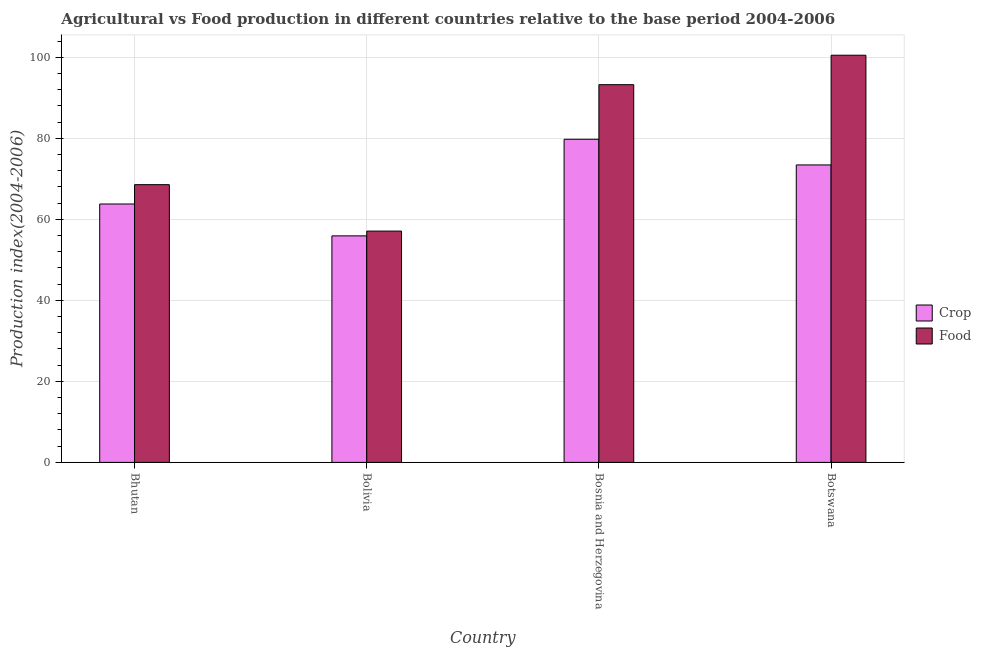How many groups of bars are there?
Your response must be concise. 4. How many bars are there on the 2nd tick from the left?
Your answer should be very brief. 2. How many bars are there on the 1st tick from the right?
Keep it short and to the point. 2. What is the label of the 4th group of bars from the left?
Provide a short and direct response. Botswana. What is the food production index in Bhutan?
Give a very brief answer. 68.56. Across all countries, what is the maximum crop production index?
Provide a succinct answer. 79.77. Across all countries, what is the minimum food production index?
Keep it short and to the point. 57.1. In which country was the food production index maximum?
Make the answer very short. Botswana. What is the total crop production index in the graph?
Offer a terse response. 272.91. What is the difference between the crop production index in Bhutan and that in Botswana?
Ensure brevity in your answer.  -9.64. What is the difference between the food production index in Bolivia and the crop production index in Botswana?
Keep it short and to the point. -16.33. What is the average food production index per country?
Offer a very short reply. 79.85. What is the difference between the food production index and crop production index in Bosnia and Herzegovina?
Offer a terse response. 13.47. In how many countries, is the food production index greater than 64 ?
Give a very brief answer. 3. What is the ratio of the food production index in Bhutan to that in Botswana?
Offer a very short reply. 0.68. Is the crop production index in Bolivia less than that in Botswana?
Ensure brevity in your answer.  Yes. What is the difference between the highest and the second highest food production index?
Give a very brief answer. 7.27. What is the difference between the highest and the lowest food production index?
Offer a very short reply. 43.41. In how many countries, is the crop production index greater than the average crop production index taken over all countries?
Your answer should be compact. 2. What does the 1st bar from the left in Botswana represents?
Your answer should be very brief. Crop. What does the 2nd bar from the right in Bosnia and Herzegovina represents?
Provide a succinct answer. Crop. How many bars are there?
Give a very brief answer. 8. How many countries are there in the graph?
Your response must be concise. 4. What is the difference between two consecutive major ticks on the Y-axis?
Your answer should be very brief. 20. Does the graph contain any zero values?
Give a very brief answer. No. Where does the legend appear in the graph?
Your answer should be very brief. Center right. What is the title of the graph?
Your answer should be compact. Agricultural vs Food production in different countries relative to the base period 2004-2006. What is the label or title of the X-axis?
Provide a short and direct response. Country. What is the label or title of the Y-axis?
Make the answer very short. Production index(2004-2006). What is the Production index(2004-2006) in Crop in Bhutan?
Your answer should be very brief. 63.79. What is the Production index(2004-2006) in Food in Bhutan?
Your answer should be very brief. 68.56. What is the Production index(2004-2006) of Crop in Bolivia?
Provide a succinct answer. 55.92. What is the Production index(2004-2006) in Food in Bolivia?
Your answer should be compact. 57.1. What is the Production index(2004-2006) in Crop in Bosnia and Herzegovina?
Your answer should be very brief. 79.77. What is the Production index(2004-2006) of Food in Bosnia and Herzegovina?
Your response must be concise. 93.24. What is the Production index(2004-2006) in Crop in Botswana?
Provide a short and direct response. 73.43. What is the Production index(2004-2006) in Food in Botswana?
Ensure brevity in your answer.  100.51. Across all countries, what is the maximum Production index(2004-2006) in Crop?
Keep it short and to the point. 79.77. Across all countries, what is the maximum Production index(2004-2006) of Food?
Your answer should be very brief. 100.51. Across all countries, what is the minimum Production index(2004-2006) of Crop?
Make the answer very short. 55.92. Across all countries, what is the minimum Production index(2004-2006) of Food?
Your answer should be compact. 57.1. What is the total Production index(2004-2006) in Crop in the graph?
Ensure brevity in your answer.  272.91. What is the total Production index(2004-2006) in Food in the graph?
Provide a short and direct response. 319.41. What is the difference between the Production index(2004-2006) of Crop in Bhutan and that in Bolivia?
Give a very brief answer. 7.87. What is the difference between the Production index(2004-2006) of Food in Bhutan and that in Bolivia?
Make the answer very short. 11.46. What is the difference between the Production index(2004-2006) of Crop in Bhutan and that in Bosnia and Herzegovina?
Provide a short and direct response. -15.98. What is the difference between the Production index(2004-2006) of Food in Bhutan and that in Bosnia and Herzegovina?
Ensure brevity in your answer.  -24.68. What is the difference between the Production index(2004-2006) in Crop in Bhutan and that in Botswana?
Your response must be concise. -9.64. What is the difference between the Production index(2004-2006) in Food in Bhutan and that in Botswana?
Provide a succinct answer. -31.95. What is the difference between the Production index(2004-2006) in Crop in Bolivia and that in Bosnia and Herzegovina?
Keep it short and to the point. -23.85. What is the difference between the Production index(2004-2006) of Food in Bolivia and that in Bosnia and Herzegovina?
Make the answer very short. -36.14. What is the difference between the Production index(2004-2006) in Crop in Bolivia and that in Botswana?
Your response must be concise. -17.51. What is the difference between the Production index(2004-2006) in Food in Bolivia and that in Botswana?
Your response must be concise. -43.41. What is the difference between the Production index(2004-2006) of Crop in Bosnia and Herzegovina and that in Botswana?
Offer a terse response. 6.34. What is the difference between the Production index(2004-2006) in Food in Bosnia and Herzegovina and that in Botswana?
Offer a very short reply. -7.27. What is the difference between the Production index(2004-2006) of Crop in Bhutan and the Production index(2004-2006) of Food in Bolivia?
Offer a terse response. 6.69. What is the difference between the Production index(2004-2006) in Crop in Bhutan and the Production index(2004-2006) in Food in Bosnia and Herzegovina?
Provide a succinct answer. -29.45. What is the difference between the Production index(2004-2006) of Crop in Bhutan and the Production index(2004-2006) of Food in Botswana?
Your response must be concise. -36.72. What is the difference between the Production index(2004-2006) in Crop in Bolivia and the Production index(2004-2006) in Food in Bosnia and Herzegovina?
Your response must be concise. -37.32. What is the difference between the Production index(2004-2006) in Crop in Bolivia and the Production index(2004-2006) in Food in Botswana?
Give a very brief answer. -44.59. What is the difference between the Production index(2004-2006) in Crop in Bosnia and Herzegovina and the Production index(2004-2006) in Food in Botswana?
Your answer should be compact. -20.74. What is the average Production index(2004-2006) of Crop per country?
Give a very brief answer. 68.23. What is the average Production index(2004-2006) in Food per country?
Keep it short and to the point. 79.85. What is the difference between the Production index(2004-2006) of Crop and Production index(2004-2006) of Food in Bhutan?
Provide a succinct answer. -4.77. What is the difference between the Production index(2004-2006) of Crop and Production index(2004-2006) of Food in Bolivia?
Ensure brevity in your answer.  -1.18. What is the difference between the Production index(2004-2006) in Crop and Production index(2004-2006) in Food in Bosnia and Herzegovina?
Ensure brevity in your answer.  -13.47. What is the difference between the Production index(2004-2006) in Crop and Production index(2004-2006) in Food in Botswana?
Your answer should be compact. -27.08. What is the ratio of the Production index(2004-2006) of Crop in Bhutan to that in Bolivia?
Ensure brevity in your answer.  1.14. What is the ratio of the Production index(2004-2006) in Food in Bhutan to that in Bolivia?
Offer a very short reply. 1.2. What is the ratio of the Production index(2004-2006) in Crop in Bhutan to that in Bosnia and Herzegovina?
Make the answer very short. 0.8. What is the ratio of the Production index(2004-2006) in Food in Bhutan to that in Bosnia and Herzegovina?
Provide a short and direct response. 0.74. What is the ratio of the Production index(2004-2006) of Crop in Bhutan to that in Botswana?
Ensure brevity in your answer.  0.87. What is the ratio of the Production index(2004-2006) in Food in Bhutan to that in Botswana?
Provide a succinct answer. 0.68. What is the ratio of the Production index(2004-2006) of Crop in Bolivia to that in Bosnia and Herzegovina?
Ensure brevity in your answer.  0.7. What is the ratio of the Production index(2004-2006) of Food in Bolivia to that in Bosnia and Herzegovina?
Make the answer very short. 0.61. What is the ratio of the Production index(2004-2006) in Crop in Bolivia to that in Botswana?
Keep it short and to the point. 0.76. What is the ratio of the Production index(2004-2006) of Food in Bolivia to that in Botswana?
Provide a succinct answer. 0.57. What is the ratio of the Production index(2004-2006) of Crop in Bosnia and Herzegovina to that in Botswana?
Give a very brief answer. 1.09. What is the ratio of the Production index(2004-2006) in Food in Bosnia and Herzegovina to that in Botswana?
Your response must be concise. 0.93. What is the difference between the highest and the second highest Production index(2004-2006) of Crop?
Your answer should be compact. 6.34. What is the difference between the highest and the second highest Production index(2004-2006) in Food?
Provide a succinct answer. 7.27. What is the difference between the highest and the lowest Production index(2004-2006) of Crop?
Provide a succinct answer. 23.85. What is the difference between the highest and the lowest Production index(2004-2006) in Food?
Offer a very short reply. 43.41. 